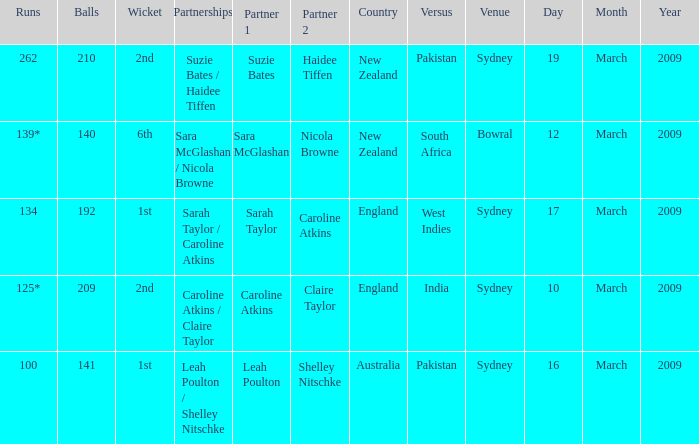How many times was the opponent country India?  1.0. 